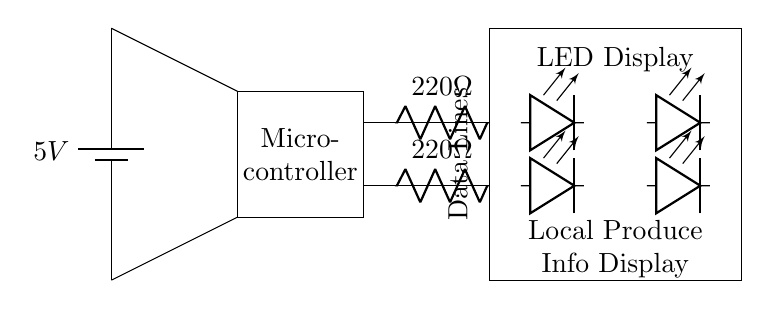What is the type of power supply used in this circuit? The circuit utilizes a battery as its power supply, indicated by the battery symbol and labeled as 5V.
Answer: Battery How many LEDs are present in this circuit? The circuit shows a total of four LEDs, arranged in two rows, with two LEDs in each row.
Answer: Four What is the purpose of the resistors in the circuit? The resistors are used to limit the current flowing through the LEDs, preventing them from burning out due to excessive current.
Answer: Current limiting What is the voltage rating of the power supply? The power supply is labeled with a voltage of 5V, specifying the potential difference it provides to the circuit.
Answer: 5V Which component is responsible for controlling the LED display? The microcontroller is responsible for managing the LED display, as denoted by its labeling and positioning within the circuit.
Answer: Microcontroller How are the LED display and microcontroller connected? The LED display is connected to the microcontroller through data lines that carry the information necessary for displaying the content.
Answer: Data Lines What is the resistance of each resistor in the circuit? Each resistor in the circuit is labeled with a resistance value of 220 ohms, which helps control the current through the LEDs.
Answer: 220 ohms 